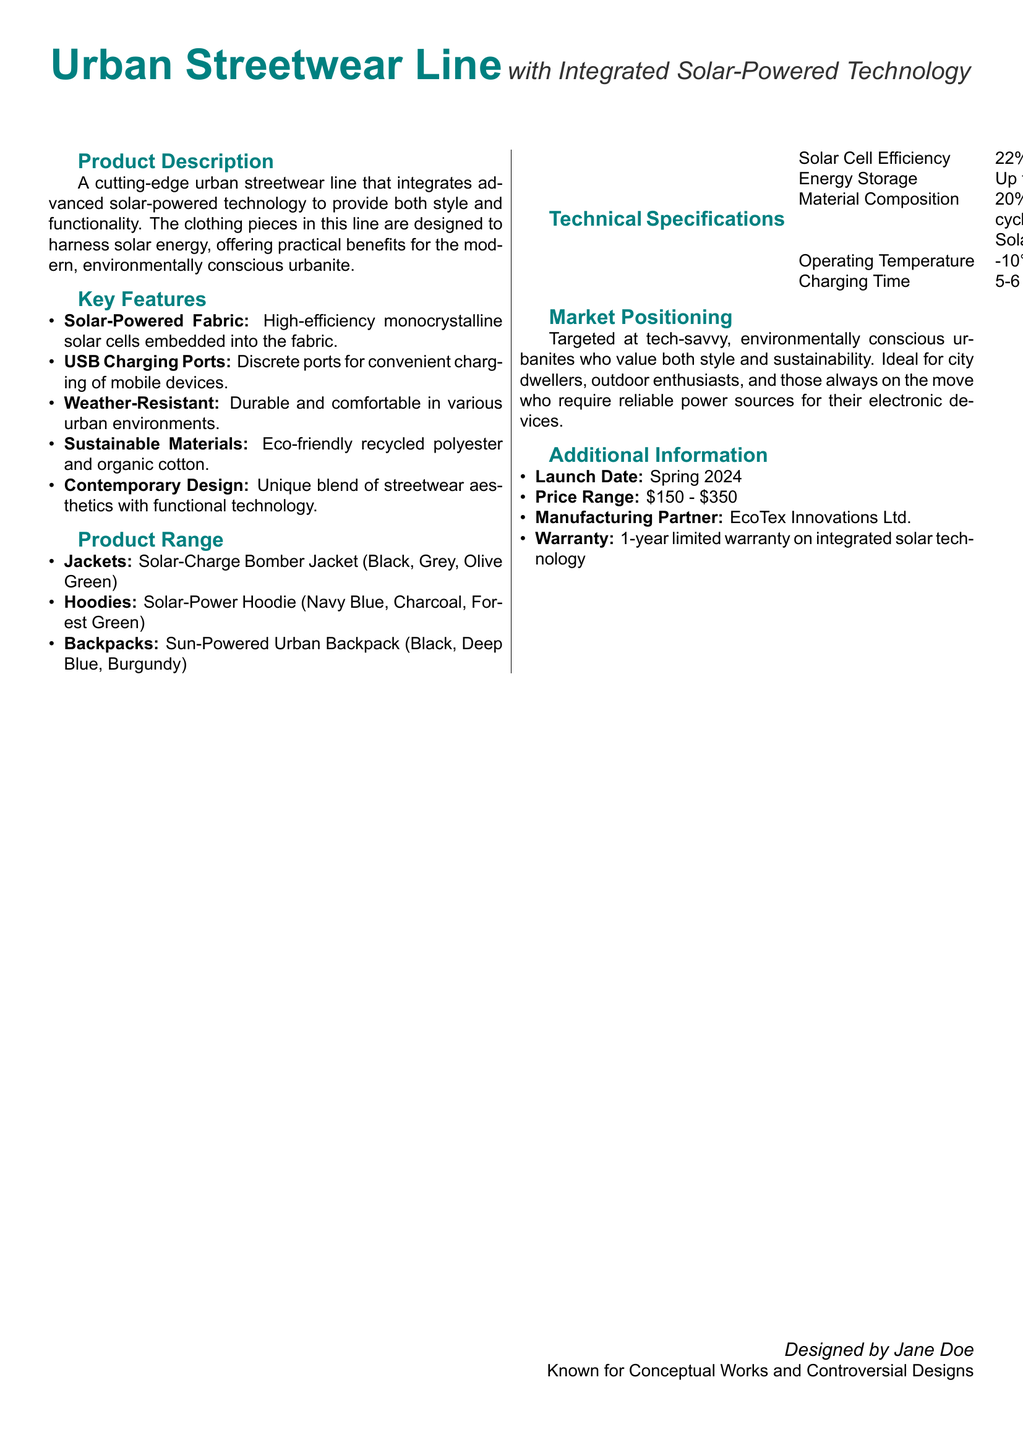what is the product description? The product description provides an overview of the urban streetwear line, emphasizing its integration of solar-powered technology for style and functionality.
Answer: A cutting-edge urban streetwear line that integrates advanced solar-powered technology to provide both style and functionality what is the energy storage capacity? The energy storage capacity is mentioned in the technical specifications section of the document.
Answer: Up to 10,000 mAh what are the available colors for the Solar-Charge Bomber Jacket? The available colors for the jacket are listed under the product range section.
Answer: Black, Grey, Olive Green who is the manufacturing partner? The manufacturing partner is specified in the additional information section.
Answer: EcoTex Innovations Ltd what is the warranty period for the integrated solar technology? The warranty period is stated in the additional information section of the document.
Answer: 1-year limited warranty which target audience is specified for the product? The target audience is identified in the market positioning section of the document.
Answer: Tech-savvy, environmentally conscious urbanites what is the charging time under direct sunlight? The charging time is provided in the technical specifications section.
Answer: 5-6 hours what materials are used in the fabric? The material composition can be found in the technical specifications section.
Answer: 20% Organic Cotton, 40% Recycled Polyester, 40% Flexible Solar Cells when is the launch date? The launch date is indicated in the additional information section of the document.
Answer: Spring 2024 